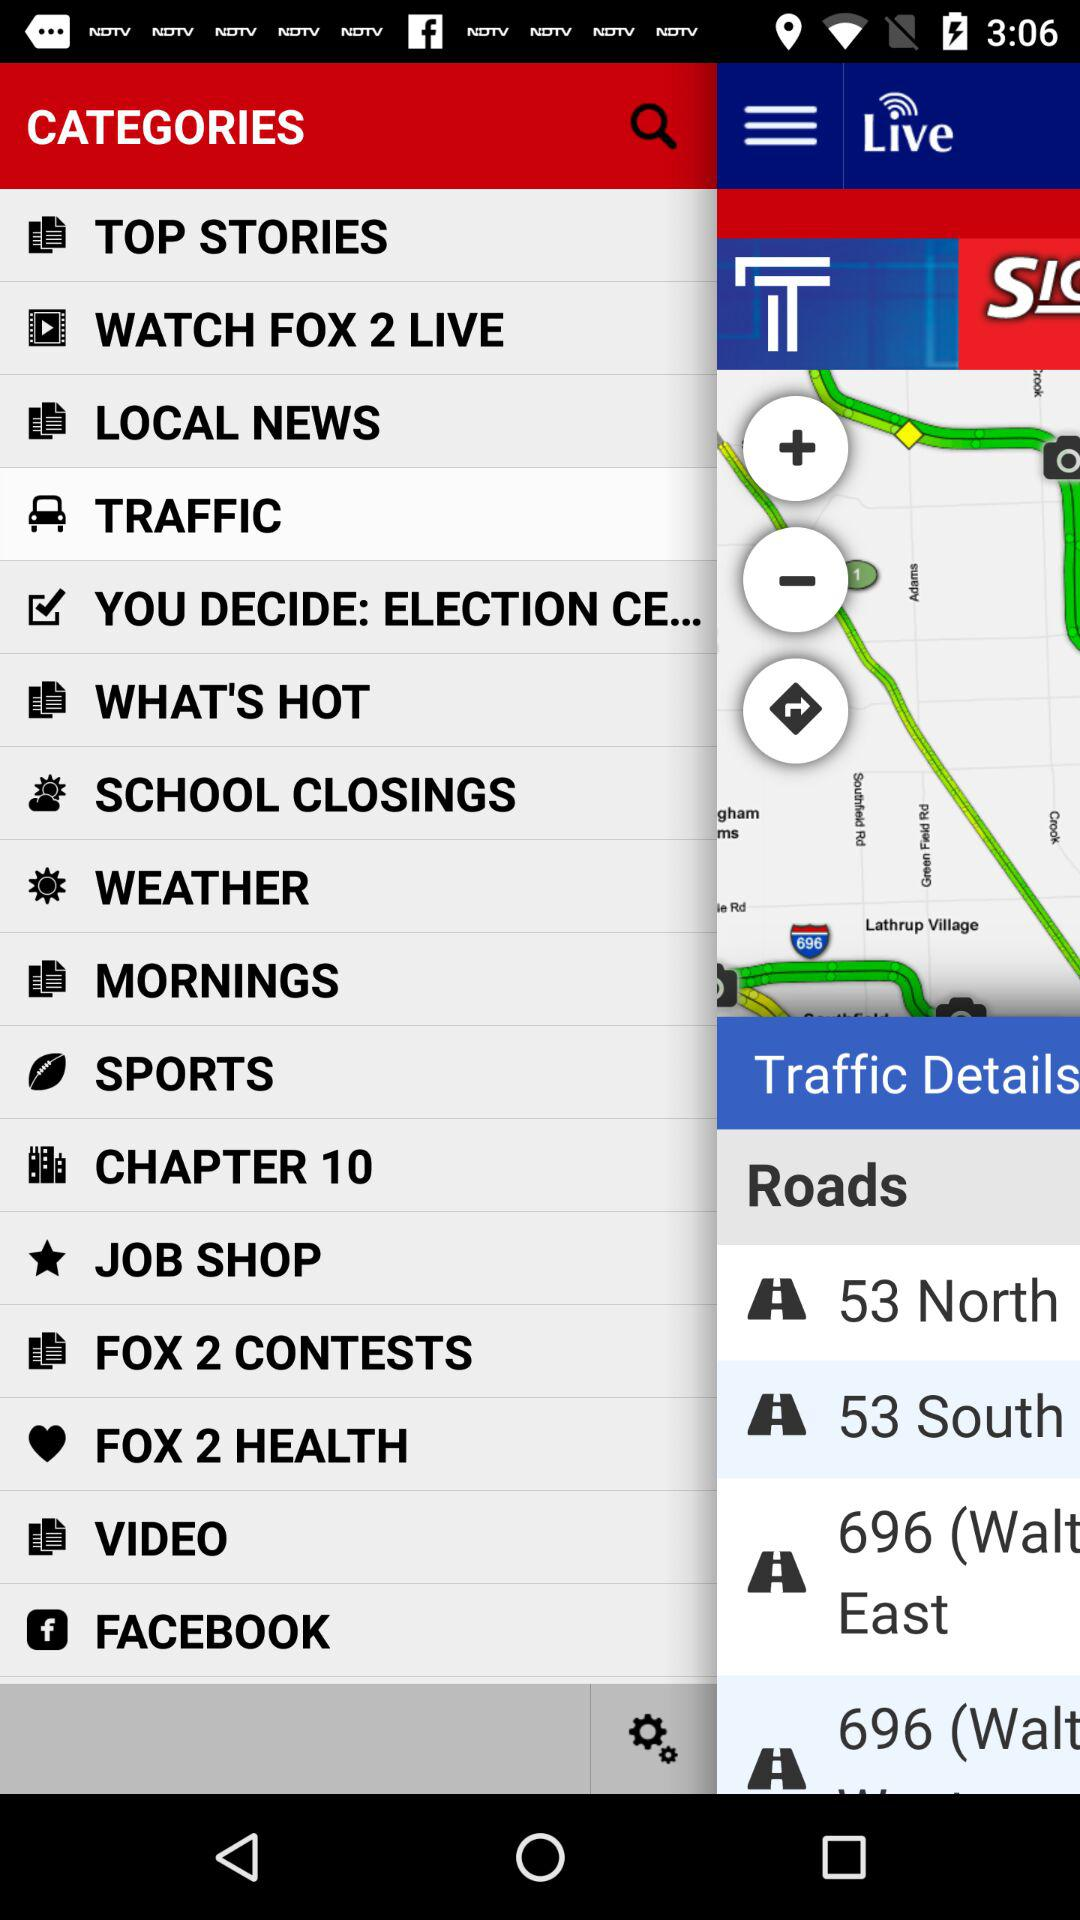What is the selected category? The selected category is "TRAFFIC". 